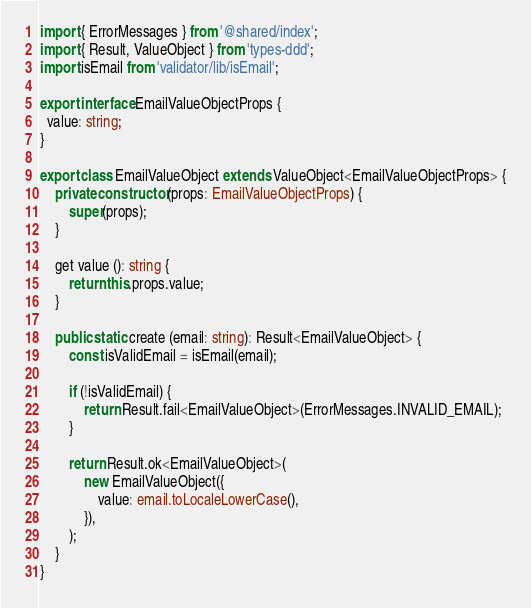Convert code to text. <code><loc_0><loc_0><loc_500><loc_500><_TypeScript_>import { ErrorMessages } from '@shared/index';
import { Result, ValueObject } from 'types-ddd';
import isEmail from 'validator/lib/isEmail';

export interface EmailValueObjectProps {
  value: string;
}

export class EmailValueObject extends ValueObject<EmailValueObjectProps> {
	private constructor (props: EmailValueObjectProps) {
		super(props);
	}

	get value (): string {
		return this.props.value;
	}

	public static create (email: string): Result<EmailValueObject> {
		const isValidEmail = isEmail(email);

		if (!isValidEmail) {
			return Result.fail<EmailValueObject>(ErrorMessages.INVALID_EMAIL);
		}

		return Result.ok<EmailValueObject>(
			new EmailValueObject({
				value: email.toLocaleLowerCase(),
			}),
		);
	}
}
</code> 